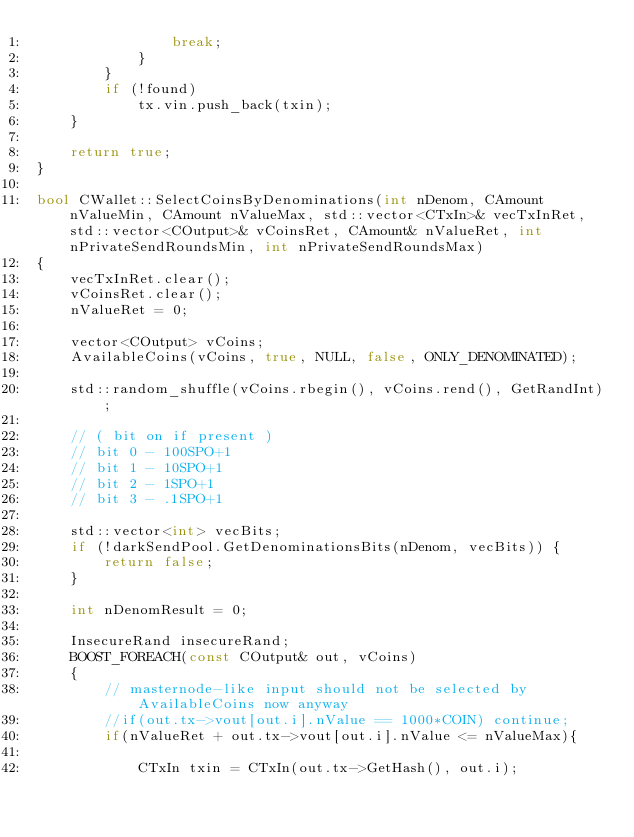<code> <loc_0><loc_0><loc_500><loc_500><_C++_>                break;
            }
        }
        if (!found)
            tx.vin.push_back(txin);
    }

    return true;
}

bool CWallet::SelectCoinsByDenominations(int nDenom, CAmount nValueMin, CAmount nValueMax, std::vector<CTxIn>& vecTxInRet, std::vector<COutput>& vCoinsRet, CAmount& nValueRet, int nPrivateSendRoundsMin, int nPrivateSendRoundsMax)
{
    vecTxInRet.clear();
    vCoinsRet.clear();
    nValueRet = 0;

    vector<COutput> vCoins;
    AvailableCoins(vCoins, true, NULL, false, ONLY_DENOMINATED);

    std::random_shuffle(vCoins.rbegin(), vCoins.rend(), GetRandInt);

    // ( bit on if present )
    // bit 0 - 100SPO+1
    // bit 1 - 10SPO+1
    // bit 2 - 1SPO+1
    // bit 3 - .1SPO+1

    std::vector<int> vecBits;
    if (!darkSendPool.GetDenominationsBits(nDenom, vecBits)) {
        return false;
    }

    int nDenomResult = 0;

    InsecureRand insecureRand;
    BOOST_FOREACH(const COutput& out, vCoins)
    {
        // masternode-like input should not be selected by AvailableCoins now anyway
        //if(out.tx->vout[out.i].nValue == 1000*COIN) continue;
        if(nValueRet + out.tx->vout[out.i].nValue <= nValueMax){

            CTxIn txin = CTxIn(out.tx->GetHash(), out.i);
</code> 